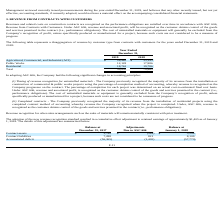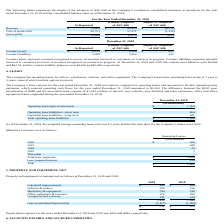According to Sunworks's financial document, What is the  Revenue as reported? According to the financial document, $70,965. The relevant text states: "Total 59,830 70,965..." Also, When will cost of uninstalled materials or equipment be included in the recognition of profit? specifically produced or manufactured for a project, because such costs are not considered to be a measure of progress. The document states: "from the Company’s recognition of profit, unless specifically produced or manufactured for a project, because such costs are not considered to be a me..." Also, What does the table show? the impact of the adoption of ASC 606 on the Company’s condensed consolidated statement of operations for the year ended December 31, 2018 and the consolidated balance sheet as of December 31, 2018. The document states: "The following tables summarize the impact of the adoption of ASC 606 on the Company’s condensed consolidated statement of operations for the year ende..." Also, can you calculate: What is the percentage change in revenue after the adoption of ASC 606? To answer this question, I need to perform calculations using the financial data. The calculation is: (70,965-68,845)/68,845, which equals 3.08 (percentage). This is based on the information: "Total 59,830 70,965 Revenue $ 70,965 $ 68,845 $ (2,120)..." The key data points involved are: 68,845, 70,965. Also, can you calculate: What is the percentage change in the costs of goods sold after the adoption of ASC 606? To answer this question, I need to perform calculations using the financial data. The calculation is: (58,701-57,471)/57,471, which equals 2.14 (percentage). This is based on the information: "Cost of goods sold 58,701 57,471 (1,230) Cost of goods sold 58,701 57,471 (1,230)..." The key data points involved are: 57,471, 58,701. Also, can you calculate: What is the gross profit ratio for the year ended December 31, 2018? Based on the calculation: 12,264/70,965, the result is 0.17. This is based on the information: "Total 59,830 70,965 Gross profit 12,264 11,374 (890 )..." The key data points involved are: 12,264, 70,965. 